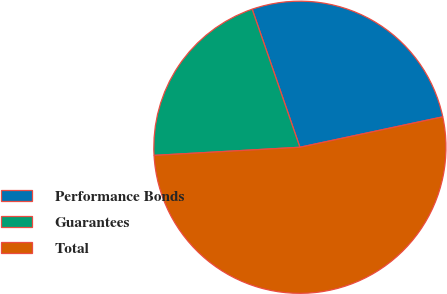Convert chart to OTSL. <chart><loc_0><loc_0><loc_500><loc_500><pie_chart><fcel>Performance Bonds<fcel>Guarantees<fcel>Total<nl><fcel>26.96%<fcel>20.59%<fcel>52.45%<nl></chart> 